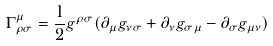Convert formula to latex. <formula><loc_0><loc_0><loc_500><loc_500>\Gamma ^ { \mu } _ { \rho \sigma } = \frac { 1 } { 2 } g ^ { \rho \sigma } ( \partial _ { \mu } g _ { \nu \sigma } + \partial _ { \nu } g _ { \sigma \mu } - \partial _ { \sigma } g _ { \mu \nu } )</formula> 